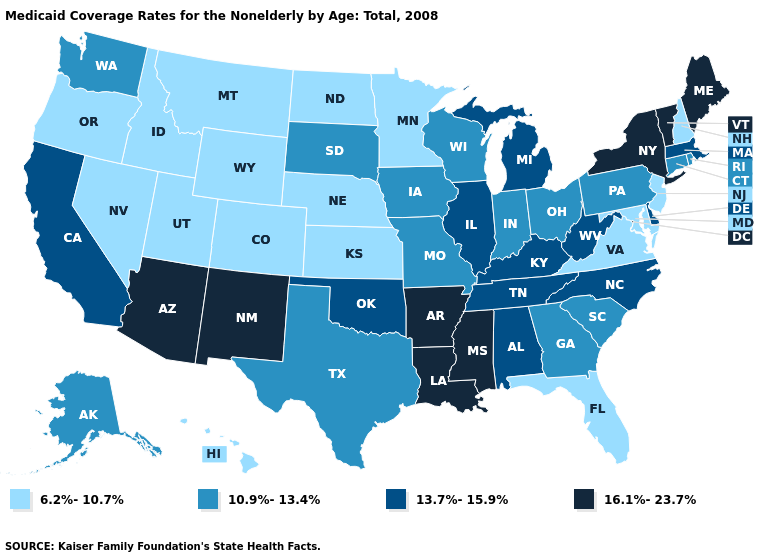Name the states that have a value in the range 10.9%-13.4%?
Concise answer only. Alaska, Connecticut, Georgia, Indiana, Iowa, Missouri, Ohio, Pennsylvania, Rhode Island, South Carolina, South Dakota, Texas, Washington, Wisconsin. Does Rhode Island have the highest value in the USA?
Quick response, please. No. Does Utah have the highest value in the USA?
Write a very short answer. No. What is the highest value in the USA?
Write a very short answer. 16.1%-23.7%. Name the states that have a value in the range 13.7%-15.9%?
Write a very short answer. Alabama, California, Delaware, Illinois, Kentucky, Massachusetts, Michigan, North Carolina, Oklahoma, Tennessee, West Virginia. What is the lowest value in the USA?
Quick response, please. 6.2%-10.7%. What is the value of Tennessee?
Give a very brief answer. 13.7%-15.9%. Does the map have missing data?
Write a very short answer. No. Which states have the lowest value in the USA?
Write a very short answer. Colorado, Florida, Hawaii, Idaho, Kansas, Maryland, Minnesota, Montana, Nebraska, Nevada, New Hampshire, New Jersey, North Dakota, Oregon, Utah, Virginia, Wyoming. Does Illinois have the lowest value in the MidWest?
Concise answer only. No. What is the value of Missouri?
Short answer required. 10.9%-13.4%. What is the highest value in the USA?
Concise answer only. 16.1%-23.7%. What is the highest value in states that border Minnesota?
Give a very brief answer. 10.9%-13.4%. What is the value of Florida?
Short answer required. 6.2%-10.7%. 